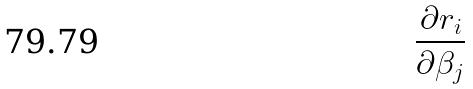Convert formula to latex. <formula><loc_0><loc_0><loc_500><loc_500>\frac { \partial r _ { i } } { \partial \beta _ { j } }</formula> 